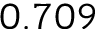Convert formula to latex. <formula><loc_0><loc_0><loc_500><loc_500>0 . 7 0 9</formula> 